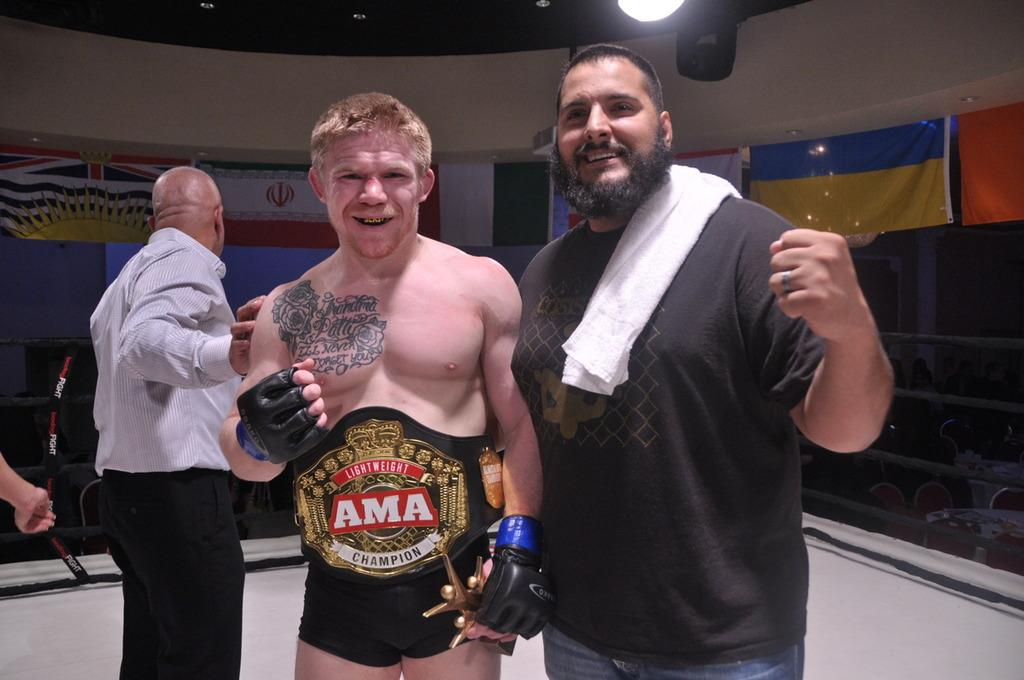<image>
Render a clear and concise summary of the photo. a fighter with the letters AMA on his belt 